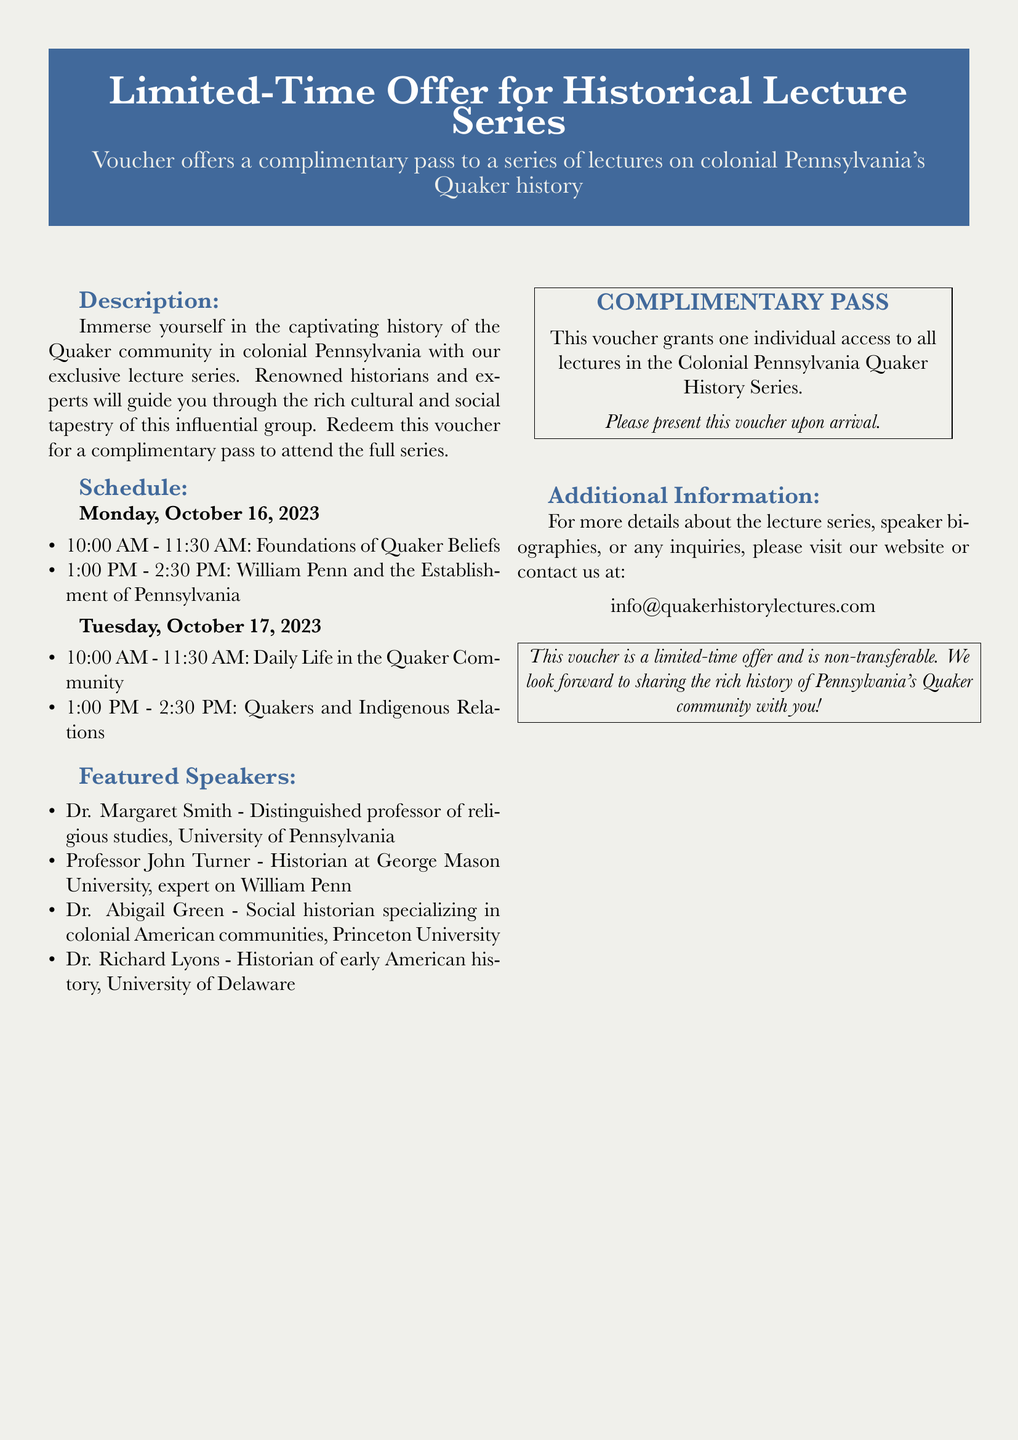What is the title of the lecture series? The document prominently features the title of the lecture series at the top, which is "Limited-Time Offer for Historical Lecture Series."
Answer: Limited-Time Offer for Historical Lecture Series Who is the speaker for "William Penn and the Establishment of Pennsylvania"? The schedule lists the first speaker for this topic, which is Professor John Turner.
Answer: Professor John Turner What is the date of the first lecture on "Foundations of Quaker Beliefs"? The schedule specifies that this lecture takes place on Monday, October 16, 2023.
Answer: Monday, October 16, 2023 How many lectures are there in total within the series? The schedule outlines four lecture topics, thus totaling four lectures within the series.
Answer: Four What university is Dr. Abigail Green affiliated with? The document provides the affiliation of Dr. Abigail Green, which is Princeton University.
Answer: Princeton University What time does the "Daily Life in the Quaker Community" lecture start? The schedule indicates that this lecture begins at 10:00 AM on Tuesday, October 17, 2023.
Answer: 10:00 AM Is the voucher transferable? The additional information in the document clearly states that the voucher is non-transferable.
Answer: Non-transferable What should you do with the voucher upon arrival? The document instructs that the voucher should be presented upon arrival at the lecture series.
Answer: Present this voucher upon arrival 